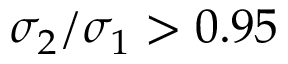<formula> <loc_0><loc_0><loc_500><loc_500>\sigma _ { 2 } / \sigma _ { 1 } > 0 . 9 5</formula> 